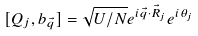Convert formula to latex. <formula><loc_0><loc_0><loc_500><loc_500>[ Q _ { j } , b _ { \vec { q } } ] = \sqrt { U / N } e ^ { i \vec { q } \cdot { \vec { R } } _ { j } } e ^ { i \theta _ { j } }</formula> 